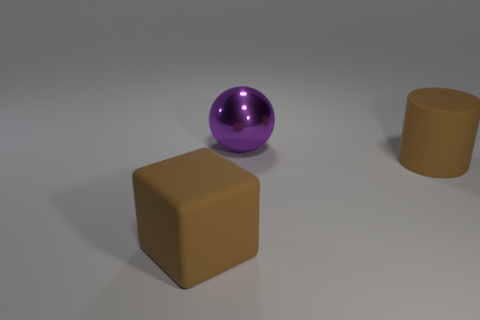Add 3 large cyan rubber objects. How many objects exist? 6 Subtract all spheres. How many objects are left? 2 Subtract 1 brown blocks. How many objects are left? 2 Subtract all large purple spheres. Subtract all big green metallic things. How many objects are left? 2 Add 1 brown cylinders. How many brown cylinders are left? 2 Add 1 big cubes. How many big cubes exist? 2 